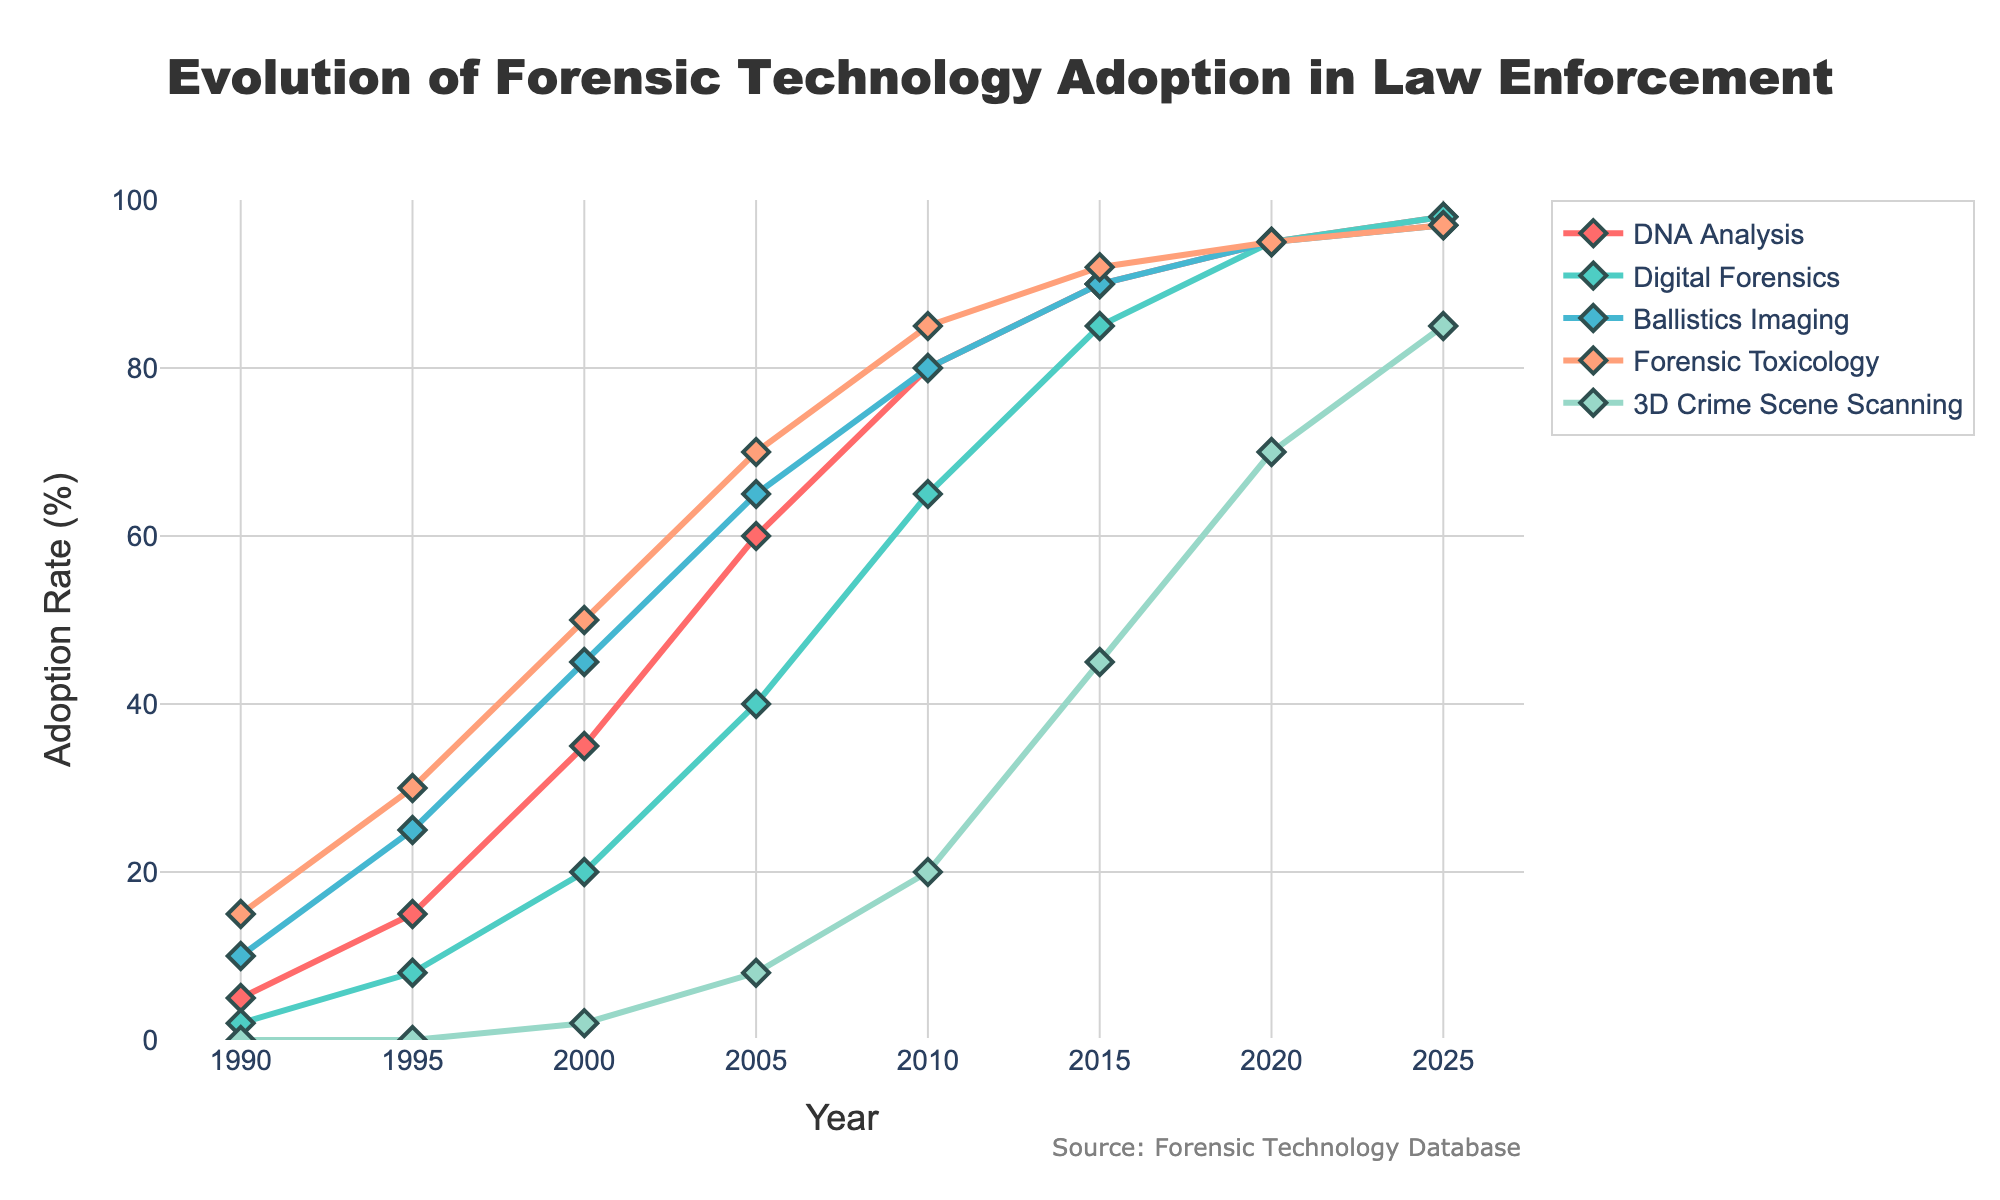What is the adoption rate of DNA Analysis in the year 2020? Look at the point on the DNA Analysis line that corresponds to the year 2020.
Answer: 95% Which forensic technology had the lowest adoption rate in 1995? Identify the lowest value among the technologies in the year 1995.
Answer: Digital Forensics How much did the adoption rate of 3D Crime Scene Scanning increase from 2000 to 2020? Subtract the 3D Crime Scene Scanning rate in 2000 from the rate in 2020 (70 - 2).
Answer: 68% What is the average adoption rate of Digital Forensics over the years shown in the chart? Add the adoption rates of Digital Forensics for all years and divide by the number of years [2+8+20+40+65+85+95+98] / 8.
Answer: 51.625% In which year did Forensic Toxicology's adoption rate first exceed 80%? Find the first year when the Forensic Toxicology line crosses above the 80% mark.
Answer: 2010 Comparing Ballistics Imaging and Forensic Toxicology, which technology had a higher adoption rate in 2005? Compare the values for Ballistics Imaging and Forensic Toxicology in the year 2005.
Answer: Forensic Toxicology What is the difference in adoption rates between the highest and lowest technologies in 2015? Identify the highest and lowest rates in 2015 and subtract the lowest from the highest (45 - 85).
Answer: 45% How many years did it take for DNA Analysis to move from below 50% adoption to above 80% adoption rate? Identify the years when the adoption rate crossed 50% and 80%, then subtract the earlier year from the later year (2010 - 2000).
Answer: 10 years What is the trend of adoption for 3D Crime Scene Scanning from 1990 to 2025? Observe the 3D Crime Scene Scanning line from start to end, noting the changes.
Answer: Increasing 